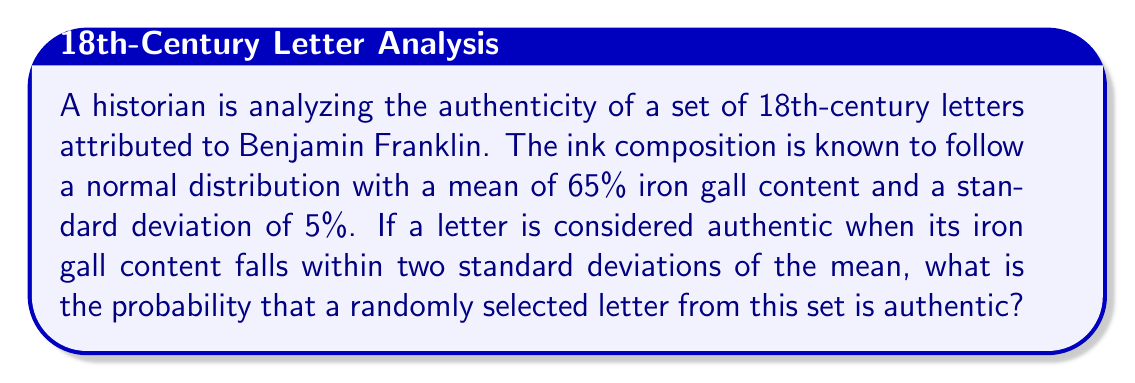Can you answer this question? To solve this problem, we need to use the properties of the normal distribution and the concept of z-scores.

1) First, let's identify the given information:
   - Mean (μ) = 65%
   - Standard deviation (σ) = 5%
   - We consider authentic letters within 2 standard deviations of the mean

2) The range for authentic letters:
   Lower bound: $65\% - (2 \times 5\%) = 55\%$
   Upper bound: $65\% + (2 \times 5\%) = 75\%$

3) To find the probability, we need to calculate the area under the normal curve between these two points. We can do this by finding the z-scores for these points and using a standard normal distribution table or calculator.

4) Z-score formula: $z = \frac{x - \mu}{\sigma}$

   For the lower bound: $z_1 = \frac{55 - 65}{5} = -2$
   For the upper bound: $z_2 = \frac{75 - 65}{5} = 2$

5) The probability we're looking for is the area between z = -2 and z = 2 in a standard normal distribution.

6) Using a standard normal distribution table or calculator:
   P(z ≤ 2) = 0.9772
   P(z ≤ -2) = 0.0228

7) The probability of a letter being authentic is:
   P(-2 ≤ z ≤ 2) = P(z ≤ 2) - P(z ≤ -2) = 0.9772 - 0.0228 = 0.9544

Therefore, the probability that a randomly selected letter is authentic is 0.9544 or about 95.44%.
Answer: 0.9544 or 95.44% 